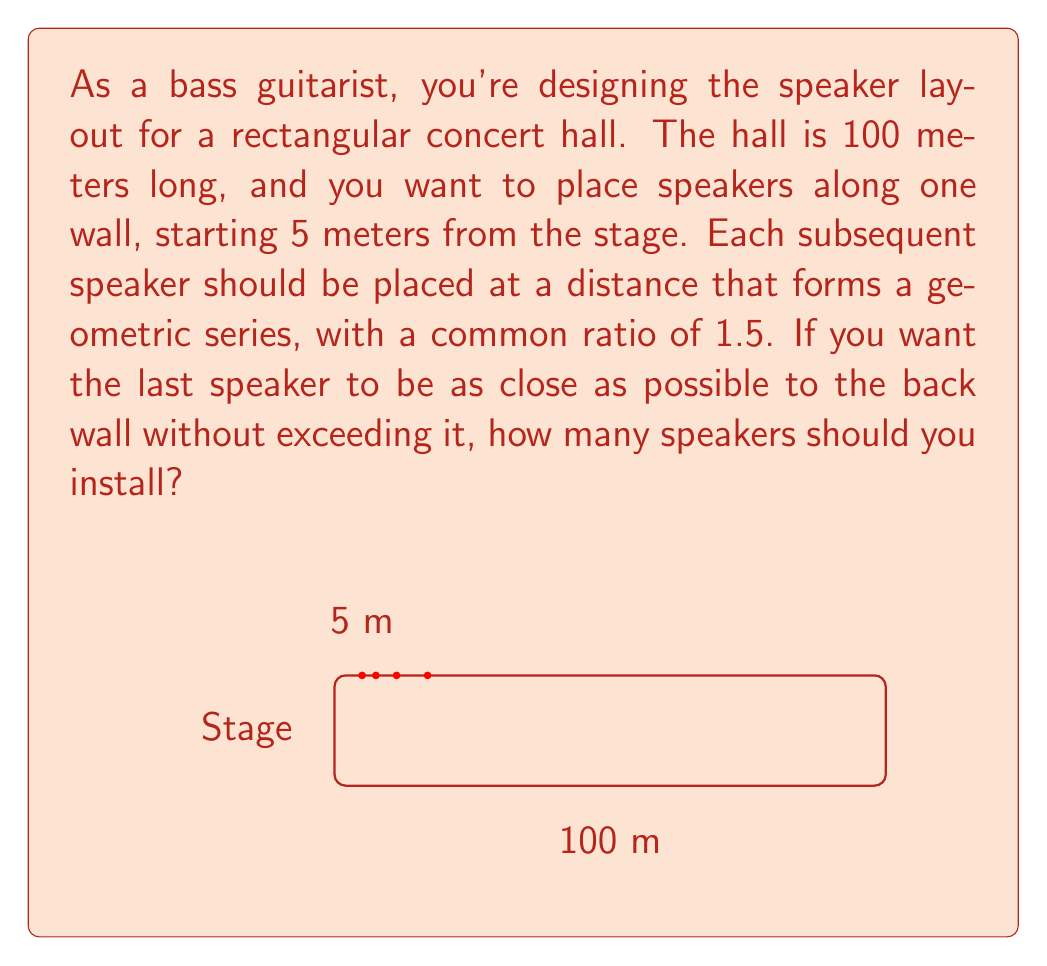Show me your answer to this math problem. Let's approach this step-by-step:

1) The geometric series for the speaker distances from the stage can be represented as:

   $$5, 5(1.5), 5(1.5)^2, 5(1.5)^3, ..., 5(1.5)^{n-1}$$

   where $n$ is the number of speakers.

2) The sum of this geometric series represents the distance of the last speaker from the stage. We want this to be as close to 100 m as possible without exceeding it.

3) The sum of a geometric series is given by the formula:

   $$S_n = a\frac{1-r^n}{1-r}$$

   where $a$ is the first term, $r$ is the common ratio, and $n$ is the number of terms.

4) In our case, $a=5$, $r=1.5$, and we want $S_n \leq 100$. So we need to solve:

   $$5\frac{1-1.5^n}{1-1.5} \leq 100$$

5) Simplifying:

   $$5\frac{1-1.5^n}{-0.5} \leq 100$$
   $$1-1.5^n \geq -10$$
   $$1.5^n \leq 11$$

6) Taking the logarithm of both sides:

   $$n\log(1.5) \leq \log(11)$$
   $$n \leq \frac{\log(11)}{\log(1.5)} \approx 7.22$$

7) Since $n$ must be a whole number, the largest value it can take is 7.

8) We can verify:
   $$5\frac{1-1.5^7}{1-1.5} \approx 98.44 \text{ m}$$
   which is indeed less than 100 m.

Therefore, you should install 7 speakers to maximize coverage without exceeding the hall length.
Answer: 7 speakers 